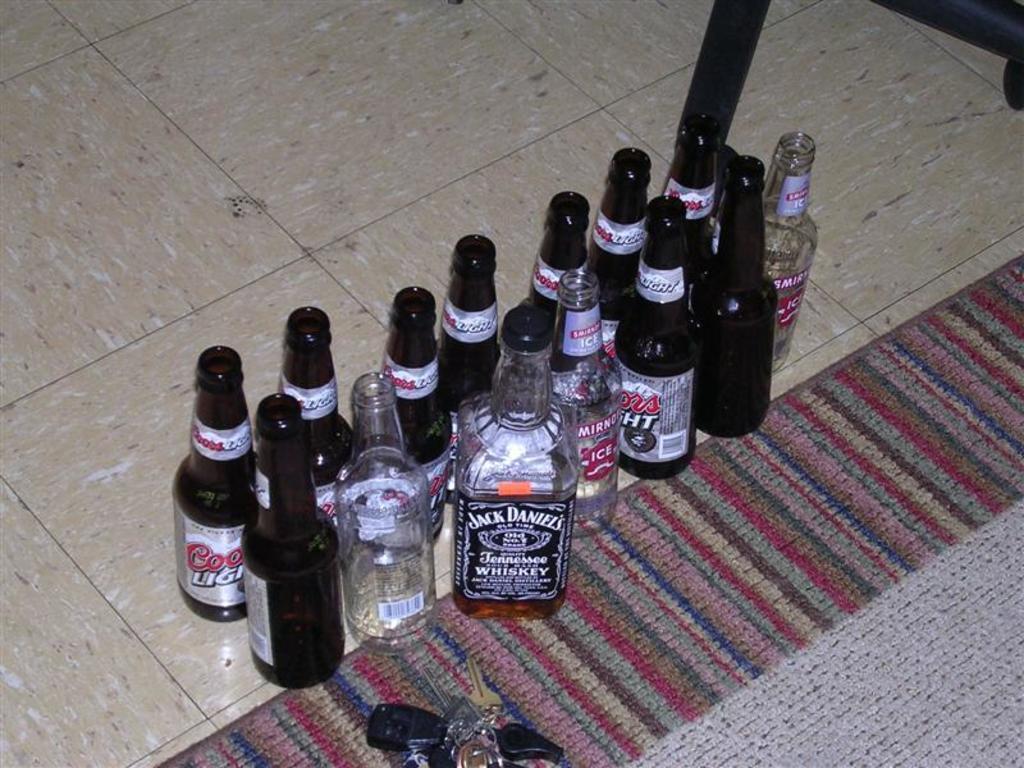Could you give a brief overview of what you see in this image? In this picture there are group of bottles on the floor. some of the bottles are empty, besides the bottles there is a bunch of keys and a mat. 